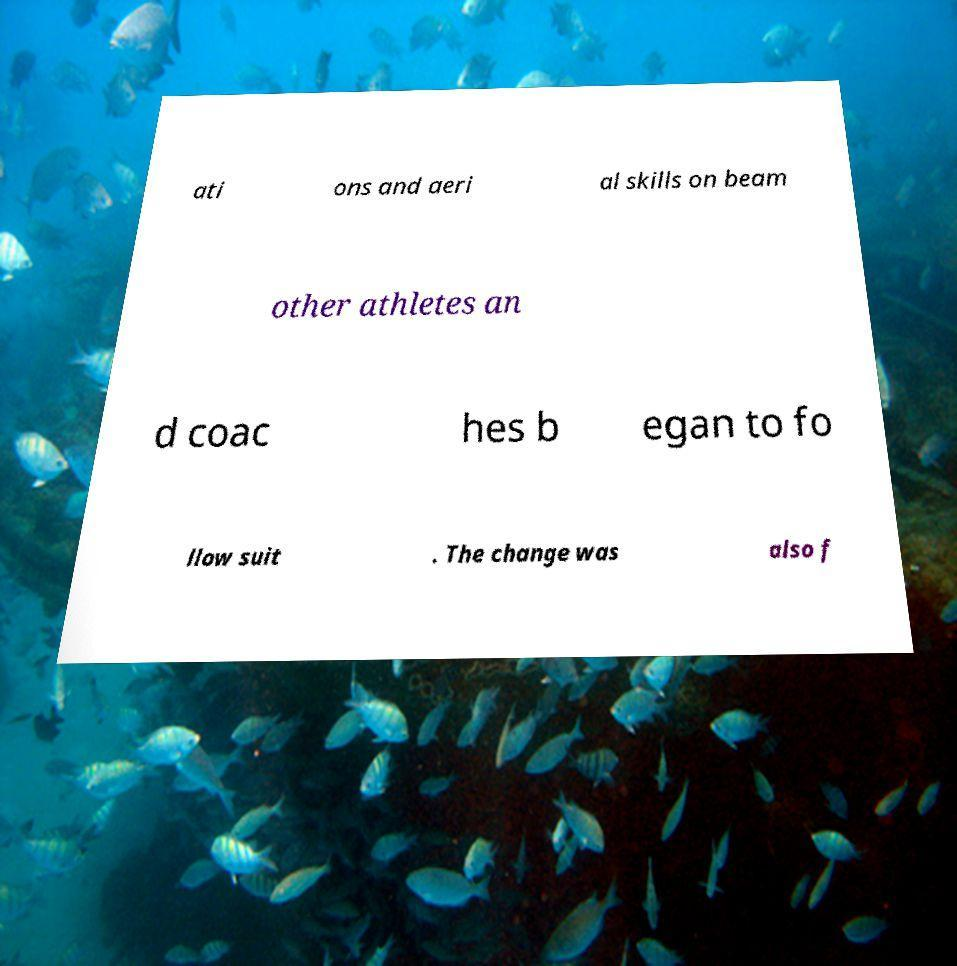Can you read and provide the text displayed in the image?This photo seems to have some interesting text. Can you extract and type it out for me? ati ons and aeri al skills on beam other athletes an d coac hes b egan to fo llow suit . The change was also f 